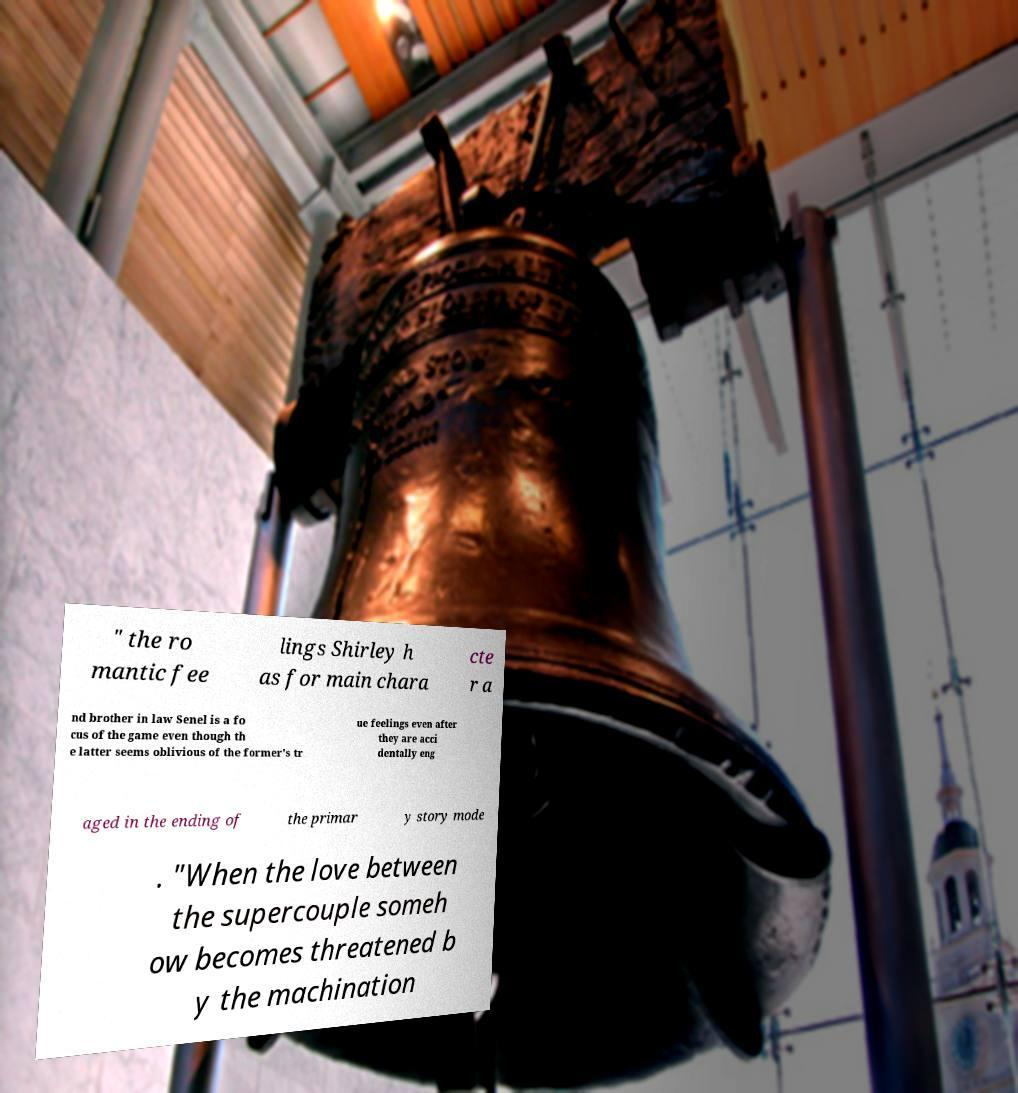For documentation purposes, I need the text within this image transcribed. Could you provide that? " the ro mantic fee lings Shirley h as for main chara cte r a nd brother in law Senel is a fo cus of the game even though th e latter seems oblivious of the former's tr ue feelings even after they are acci dentally eng aged in the ending of the primar y story mode . "When the love between the supercouple someh ow becomes threatened b y the machination 